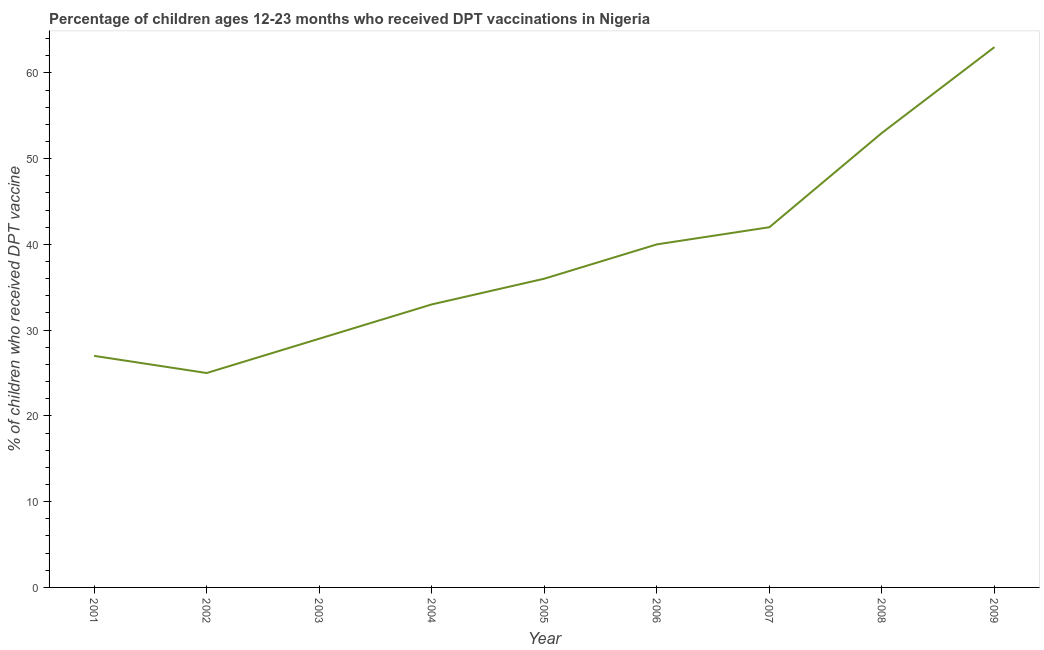What is the percentage of children who received dpt vaccine in 2008?
Provide a short and direct response. 53. Across all years, what is the maximum percentage of children who received dpt vaccine?
Keep it short and to the point. 63. Across all years, what is the minimum percentage of children who received dpt vaccine?
Your response must be concise. 25. In which year was the percentage of children who received dpt vaccine maximum?
Provide a succinct answer. 2009. In which year was the percentage of children who received dpt vaccine minimum?
Keep it short and to the point. 2002. What is the sum of the percentage of children who received dpt vaccine?
Offer a terse response. 348. What is the difference between the percentage of children who received dpt vaccine in 2004 and 2007?
Give a very brief answer. -9. What is the average percentage of children who received dpt vaccine per year?
Your answer should be compact. 38.67. What is the median percentage of children who received dpt vaccine?
Your answer should be very brief. 36. In how many years, is the percentage of children who received dpt vaccine greater than 18 %?
Keep it short and to the point. 9. Do a majority of the years between 2009 and 2004 (inclusive) have percentage of children who received dpt vaccine greater than 54 %?
Offer a very short reply. Yes. What is the ratio of the percentage of children who received dpt vaccine in 2002 to that in 2003?
Your answer should be very brief. 0.86. What is the difference between the highest and the second highest percentage of children who received dpt vaccine?
Your answer should be compact. 10. Is the sum of the percentage of children who received dpt vaccine in 2001 and 2003 greater than the maximum percentage of children who received dpt vaccine across all years?
Give a very brief answer. No. What is the difference between the highest and the lowest percentage of children who received dpt vaccine?
Offer a terse response. 38. In how many years, is the percentage of children who received dpt vaccine greater than the average percentage of children who received dpt vaccine taken over all years?
Provide a succinct answer. 4. What is the difference between two consecutive major ticks on the Y-axis?
Offer a terse response. 10. Are the values on the major ticks of Y-axis written in scientific E-notation?
Offer a terse response. No. Does the graph contain any zero values?
Provide a short and direct response. No. What is the title of the graph?
Your response must be concise. Percentage of children ages 12-23 months who received DPT vaccinations in Nigeria. What is the label or title of the Y-axis?
Provide a short and direct response. % of children who received DPT vaccine. What is the % of children who received DPT vaccine in 2002?
Keep it short and to the point. 25. What is the % of children who received DPT vaccine in 2004?
Your response must be concise. 33. What is the % of children who received DPT vaccine in 2005?
Provide a short and direct response. 36. What is the % of children who received DPT vaccine of 2006?
Your answer should be compact. 40. What is the % of children who received DPT vaccine of 2007?
Provide a succinct answer. 42. What is the % of children who received DPT vaccine in 2008?
Give a very brief answer. 53. What is the difference between the % of children who received DPT vaccine in 2001 and 2002?
Make the answer very short. 2. What is the difference between the % of children who received DPT vaccine in 2001 and 2003?
Provide a short and direct response. -2. What is the difference between the % of children who received DPT vaccine in 2001 and 2007?
Ensure brevity in your answer.  -15. What is the difference between the % of children who received DPT vaccine in 2001 and 2009?
Offer a very short reply. -36. What is the difference between the % of children who received DPT vaccine in 2002 and 2003?
Give a very brief answer. -4. What is the difference between the % of children who received DPT vaccine in 2002 and 2004?
Give a very brief answer. -8. What is the difference between the % of children who received DPT vaccine in 2002 and 2005?
Your answer should be compact. -11. What is the difference between the % of children who received DPT vaccine in 2002 and 2008?
Keep it short and to the point. -28. What is the difference between the % of children who received DPT vaccine in 2002 and 2009?
Ensure brevity in your answer.  -38. What is the difference between the % of children who received DPT vaccine in 2003 and 2007?
Offer a very short reply. -13. What is the difference between the % of children who received DPT vaccine in 2003 and 2009?
Offer a terse response. -34. What is the difference between the % of children who received DPT vaccine in 2004 and 2006?
Keep it short and to the point. -7. What is the difference between the % of children who received DPT vaccine in 2004 and 2007?
Offer a very short reply. -9. What is the difference between the % of children who received DPT vaccine in 2005 and 2007?
Make the answer very short. -6. What is the difference between the % of children who received DPT vaccine in 2006 and 2007?
Provide a short and direct response. -2. What is the difference between the % of children who received DPT vaccine in 2006 and 2008?
Ensure brevity in your answer.  -13. What is the difference between the % of children who received DPT vaccine in 2006 and 2009?
Give a very brief answer. -23. What is the difference between the % of children who received DPT vaccine in 2007 and 2008?
Ensure brevity in your answer.  -11. What is the difference between the % of children who received DPT vaccine in 2007 and 2009?
Keep it short and to the point. -21. What is the ratio of the % of children who received DPT vaccine in 2001 to that in 2003?
Make the answer very short. 0.93. What is the ratio of the % of children who received DPT vaccine in 2001 to that in 2004?
Ensure brevity in your answer.  0.82. What is the ratio of the % of children who received DPT vaccine in 2001 to that in 2006?
Your answer should be compact. 0.68. What is the ratio of the % of children who received DPT vaccine in 2001 to that in 2007?
Ensure brevity in your answer.  0.64. What is the ratio of the % of children who received DPT vaccine in 2001 to that in 2008?
Your answer should be very brief. 0.51. What is the ratio of the % of children who received DPT vaccine in 2001 to that in 2009?
Ensure brevity in your answer.  0.43. What is the ratio of the % of children who received DPT vaccine in 2002 to that in 2003?
Make the answer very short. 0.86. What is the ratio of the % of children who received DPT vaccine in 2002 to that in 2004?
Your answer should be very brief. 0.76. What is the ratio of the % of children who received DPT vaccine in 2002 to that in 2005?
Your answer should be very brief. 0.69. What is the ratio of the % of children who received DPT vaccine in 2002 to that in 2007?
Offer a terse response. 0.59. What is the ratio of the % of children who received DPT vaccine in 2002 to that in 2008?
Offer a very short reply. 0.47. What is the ratio of the % of children who received DPT vaccine in 2002 to that in 2009?
Your answer should be very brief. 0.4. What is the ratio of the % of children who received DPT vaccine in 2003 to that in 2004?
Ensure brevity in your answer.  0.88. What is the ratio of the % of children who received DPT vaccine in 2003 to that in 2005?
Keep it short and to the point. 0.81. What is the ratio of the % of children who received DPT vaccine in 2003 to that in 2006?
Ensure brevity in your answer.  0.72. What is the ratio of the % of children who received DPT vaccine in 2003 to that in 2007?
Your response must be concise. 0.69. What is the ratio of the % of children who received DPT vaccine in 2003 to that in 2008?
Offer a terse response. 0.55. What is the ratio of the % of children who received DPT vaccine in 2003 to that in 2009?
Give a very brief answer. 0.46. What is the ratio of the % of children who received DPT vaccine in 2004 to that in 2005?
Your answer should be compact. 0.92. What is the ratio of the % of children who received DPT vaccine in 2004 to that in 2006?
Make the answer very short. 0.82. What is the ratio of the % of children who received DPT vaccine in 2004 to that in 2007?
Your answer should be very brief. 0.79. What is the ratio of the % of children who received DPT vaccine in 2004 to that in 2008?
Provide a short and direct response. 0.62. What is the ratio of the % of children who received DPT vaccine in 2004 to that in 2009?
Your response must be concise. 0.52. What is the ratio of the % of children who received DPT vaccine in 2005 to that in 2007?
Make the answer very short. 0.86. What is the ratio of the % of children who received DPT vaccine in 2005 to that in 2008?
Give a very brief answer. 0.68. What is the ratio of the % of children who received DPT vaccine in 2005 to that in 2009?
Your answer should be compact. 0.57. What is the ratio of the % of children who received DPT vaccine in 2006 to that in 2007?
Your answer should be compact. 0.95. What is the ratio of the % of children who received DPT vaccine in 2006 to that in 2008?
Provide a short and direct response. 0.76. What is the ratio of the % of children who received DPT vaccine in 2006 to that in 2009?
Make the answer very short. 0.64. What is the ratio of the % of children who received DPT vaccine in 2007 to that in 2008?
Your answer should be compact. 0.79. What is the ratio of the % of children who received DPT vaccine in 2007 to that in 2009?
Give a very brief answer. 0.67. What is the ratio of the % of children who received DPT vaccine in 2008 to that in 2009?
Keep it short and to the point. 0.84. 